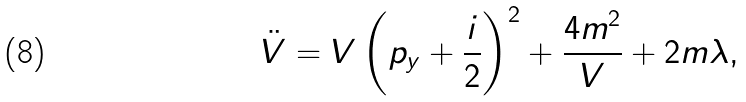Convert formula to latex. <formula><loc_0><loc_0><loc_500><loc_500>\ddot { V } = V \left ( p _ { y } + \frac { i } { 2 } \right ) ^ { 2 } + \frac { 4 m ^ { 2 } } { V } + 2 m \lambda ,</formula> 